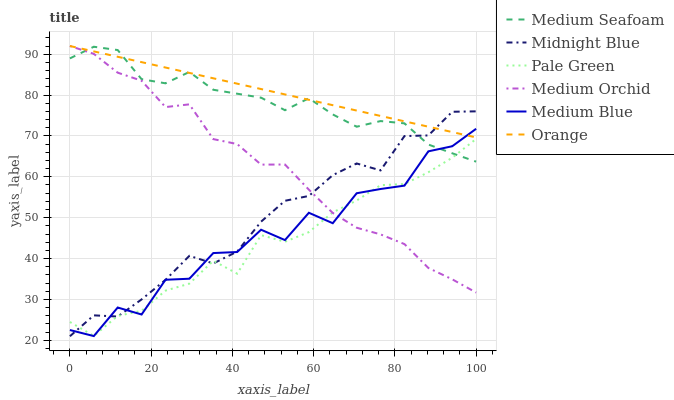Does Pale Green have the minimum area under the curve?
Answer yes or no. Yes. Does Orange have the maximum area under the curve?
Answer yes or no. Yes. Does Medium Orchid have the minimum area under the curve?
Answer yes or no. No. Does Medium Orchid have the maximum area under the curve?
Answer yes or no. No. Is Orange the smoothest?
Answer yes or no. Yes. Is Medium Blue the roughest?
Answer yes or no. Yes. Is Medium Orchid the smoothest?
Answer yes or no. No. Is Medium Orchid the roughest?
Answer yes or no. No. Does Midnight Blue have the lowest value?
Answer yes or no. Yes. Does Medium Orchid have the lowest value?
Answer yes or no. No. Does Orange have the highest value?
Answer yes or no. Yes. Does Medium Blue have the highest value?
Answer yes or no. No. Is Pale Green less than Orange?
Answer yes or no. Yes. Is Orange greater than Pale Green?
Answer yes or no. Yes. Does Midnight Blue intersect Pale Green?
Answer yes or no. Yes. Is Midnight Blue less than Pale Green?
Answer yes or no. No. Is Midnight Blue greater than Pale Green?
Answer yes or no. No. Does Pale Green intersect Orange?
Answer yes or no. No. 